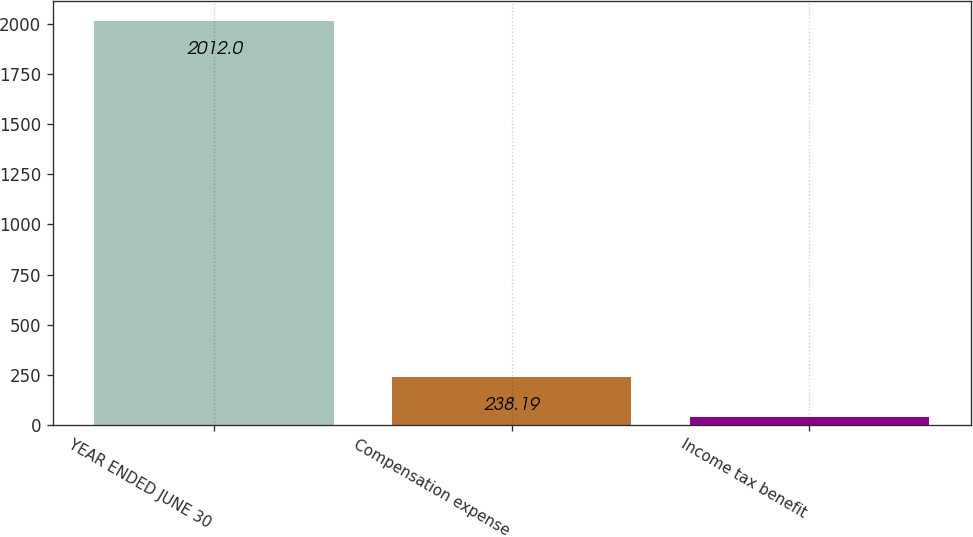Convert chart. <chart><loc_0><loc_0><loc_500><loc_500><bar_chart><fcel>YEAR ENDED JUNE 30<fcel>Compensation expense<fcel>Income tax benefit<nl><fcel>2012<fcel>238.19<fcel>41.1<nl></chart> 